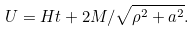Convert formula to latex. <formula><loc_0><loc_0><loc_500><loc_500>U = H t + 2 M / \sqrt { \rho ^ { 2 } + a ^ { 2 } } .</formula> 